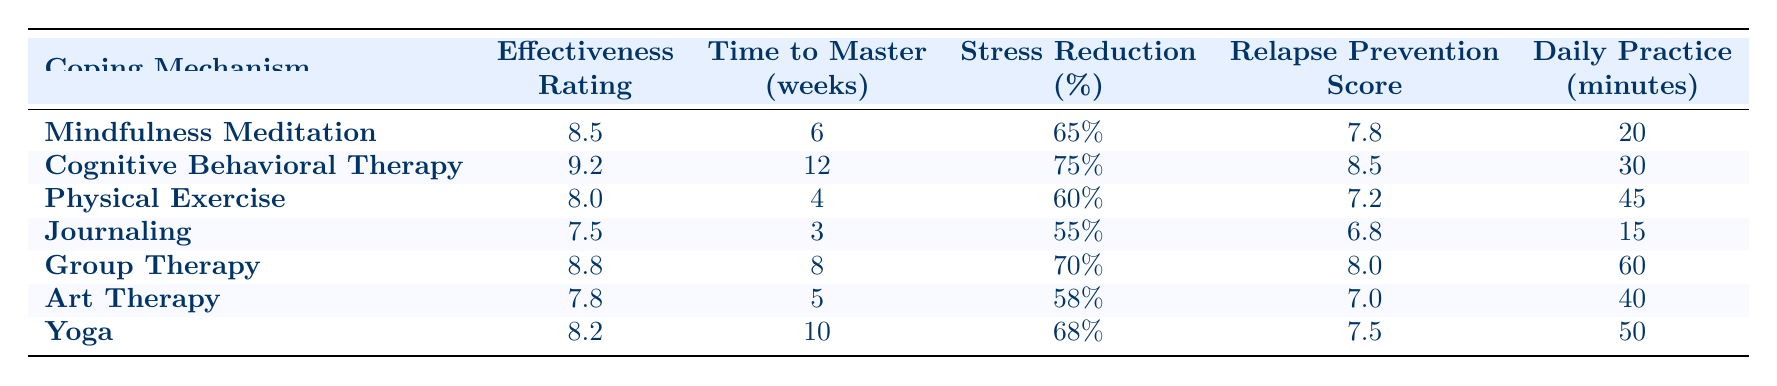What is the effectiveness rating of Cognitive Behavioral Therapy? The effectiveness rating for Cognitive Behavioral Therapy is clearly listed in the table under the "Effectiveness" column. For the row related to Cognitive Behavioral Therapy, it shows a rating of 9.2.
Answer: 9.2 Which coping mechanism has the highest stress reduction percentage? In the "Stress Reduction" column, we look for the highest value across all coping mechanisms. The highest percentage found is 75%, which corresponds to Cognitive Behavioral Therapy.
Answer: Cognitive Behavioral Therapy How long does it take to master Journaling? The "Time to Master" column shows how many weeks each coping mechanism typically requires to learn. For Journaling, it states 3 weeks.
Answer: 3 weeks What is the average effectiveness rating of the coping mechanisms listed in the table? To find the average effectiveness rating, we add the ratings of all coping mechanisms (8.5 + 9.2 + 8.0 + 7.5 + 8.8 + 7.8 + 8.2 = 58.0) and divide by the number of mechanisms (7). This gives us an average of 58.0 / 7 = 8.29.
Answer: 8.29 Does Mindfulness Meditation have a higher effectiveness rating than Physical Exercise? Comparing the effectiveness ratings in the rows for Mindfulness Meditation (8.5) and Physical Exercise (8.0), Mindfulness Meditation has the higher rating since 8.5 is greater than 8.0.
Answer: Yes Which coping mechanism requires the least daily practice time? By inspecting the "Daily Practice" column, we find that Journaling, which requires 15 minutes of practice daily, takes the least time compared to the other mechanisms listed.
Answer: Journaling What is the total daily practice time required for all coping mechanisms? To find the total, we sum the daily practice times: 20 + 30 + 45 + 15 + 60 + 40 + 50 = 250 minutes. Therefore, the total daily practice time is 250 minutes.
Answer: 250 minutes Is the relapse prevention score of Yoga higher than that of Art Therapy? Yoga has a relapse prevention score of 7.5, and Art Therapy has a score of 7.0. Since 7.5 is greater than 7.0, Yoga has a higher score.
Answer: Yes What coping mechanisms have an effectiveness rating of 8.0 or higher? By examining the "Effectiveness" column, the coping mechanisms with a rating of 8.0 or higher are Mindfulness Meditation (8.5), Cognitive Behavioral Therapy (9.2), Group Therapy (8.8), and Yoga (8.2).
Answer: Mindfulness Meditation, Cognitive Behavioral Therapy, Group Therapy, Yoga 